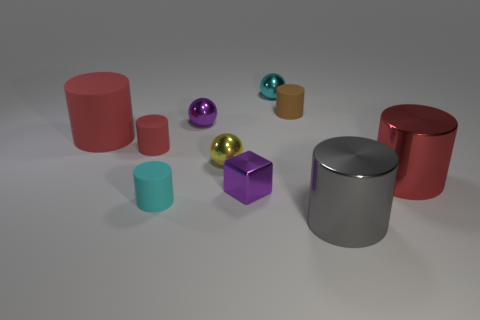Subtract all brown cylinders. How many cylinders are left? 5 Subtract all purple cubes. How many red cylinders are left? 3 Subtract 1 cylinders. How many cylinders are left? 5 Subtract all red cylinders. How many cylinders are left? 3 Subtract all purple cylinders. Subtract all red blocks. How many cylinders are left? 6 Subtract all spheres. How many objects are left? 7 Subtract 0 yellow cylinders. How many objects are left? 10 Subtract all purple cubes. Subtract all gray things. How many objects are left? 8 Add 9 big gray cylinders. How many big gray cylinders are left? 10 Add 3 large gray cylinders. How many large gray cylinders exist? 4 